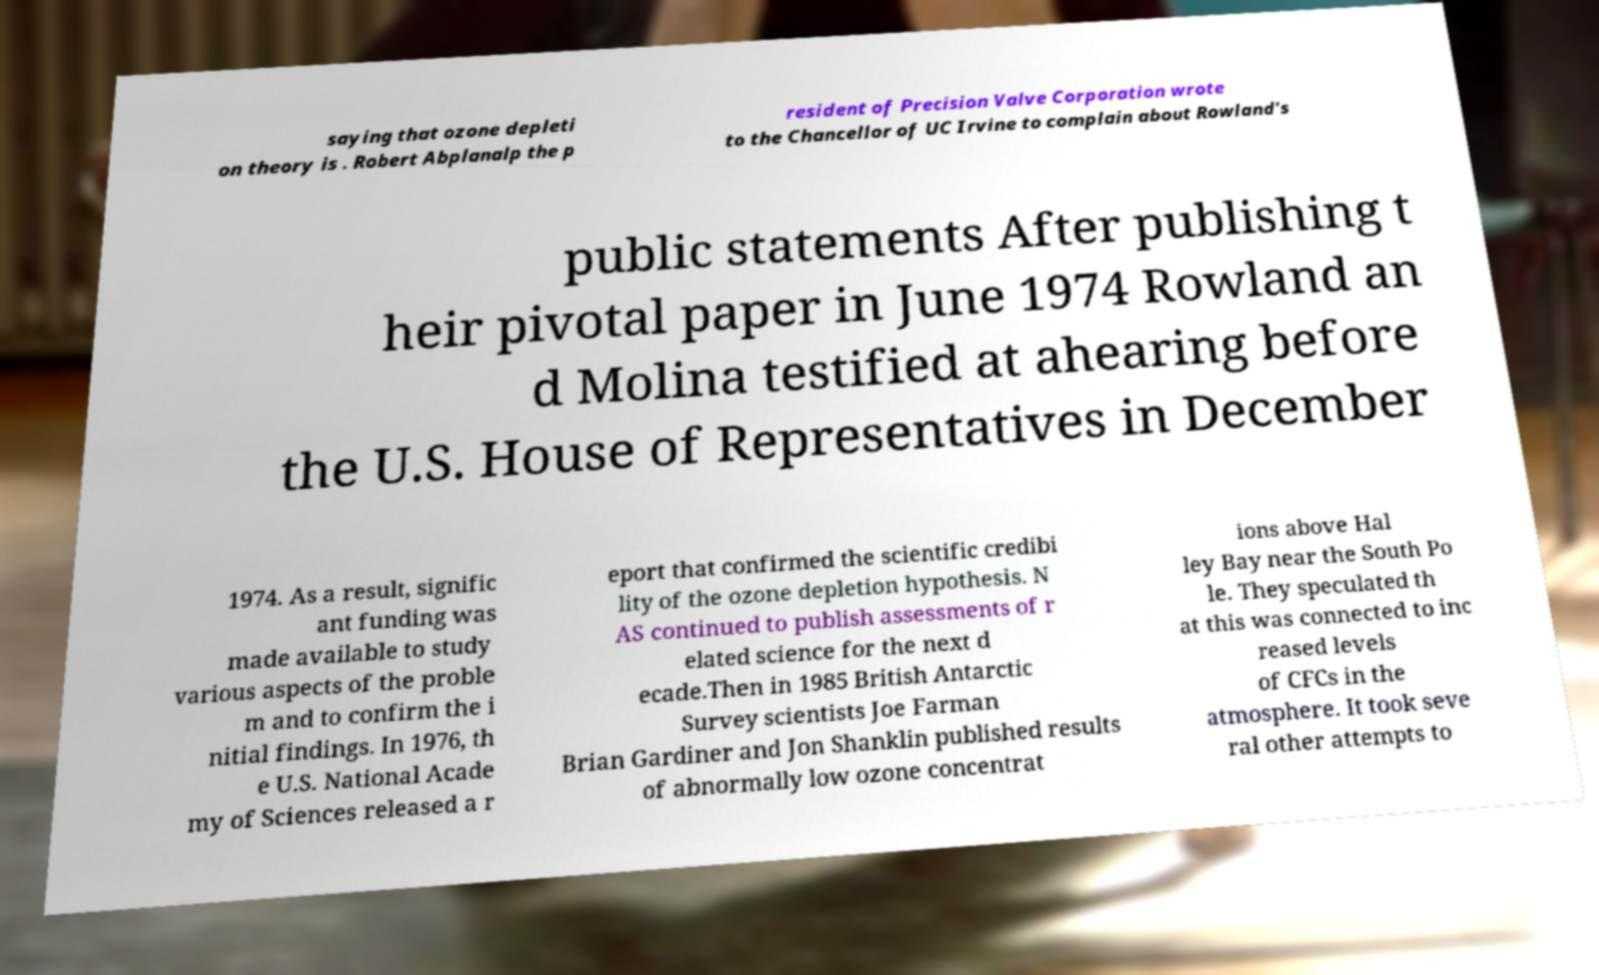Can you accurately transcribe the text from the provided image for me? saying that ozone depleti on theory is . Robert Abplanalp the p resident of Precision Valve Corporation wrote to the Chancellor of UC Irvine to complain about Rowland's public statements After publishing t heir pivotal paper in June 1974 Rowland an d Molina testified at ahearing before the U.S. House of Representatives in December 1974. As a result, signific ant funding was made available to study various aspects of the proble m and to confirm the i nitial findings. In 1976, th e U.S. National Acade my of Sciences released a r eport that confirmed the scientific credibi lity of the ozone depletion hypothesis. N AS continued to publish assessments of r elated science for the next d ecade.Then in 1985 British Antarctic Survey scientists Joe Farman Brian Gardiner and Jon Shanklin published results of abnormally low ozone concentrat ions above Hal ley Bay near the South Po le. They speculated th at this was connected to inc reased levels of CFCs in the atmosphere. It took seve ral other attempts to 